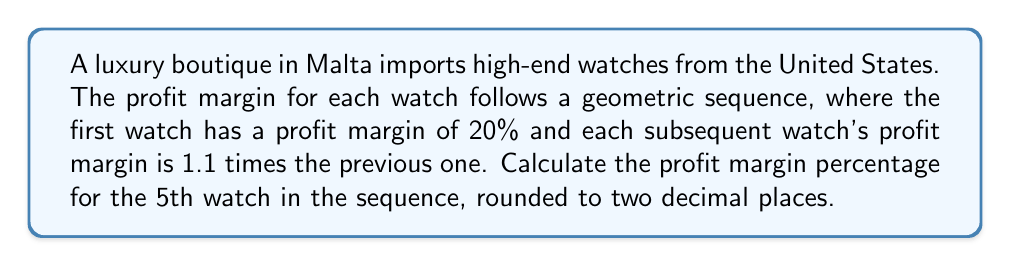Show me your answer to this math problem. Let's approach this step-by-step:

1) We're dealing with a geometric sequence where:
   - The first term, $a_1 = 20\%$ (or 0.20 in decimal form)
   - The common ratio, $r = 1.1$

2) The general formula for the nth term of a geometric sequence is:
   $$a_n = a_1 \cdot r^{n-1}$$

3) We need to find the 5th term, so n = 5:
   $$a_5 = 20\% \cdot (1.1)^{5-1}$$

4) Let's calculate:
   $$a_5 = 0.20 \cdot (1.1)^4$$
   $$a_5 = 0.20 \cdot 1.4641$$
   $$a_5 = 0.29282$$

5) Converting back to a percentage and rounding to two decimal places:
   $$a_5 \approx 29.28\%$$

Therefore, the profit margin for the 5th watch in the sequence is approximately 29.28%.
Answer: 29.28% 